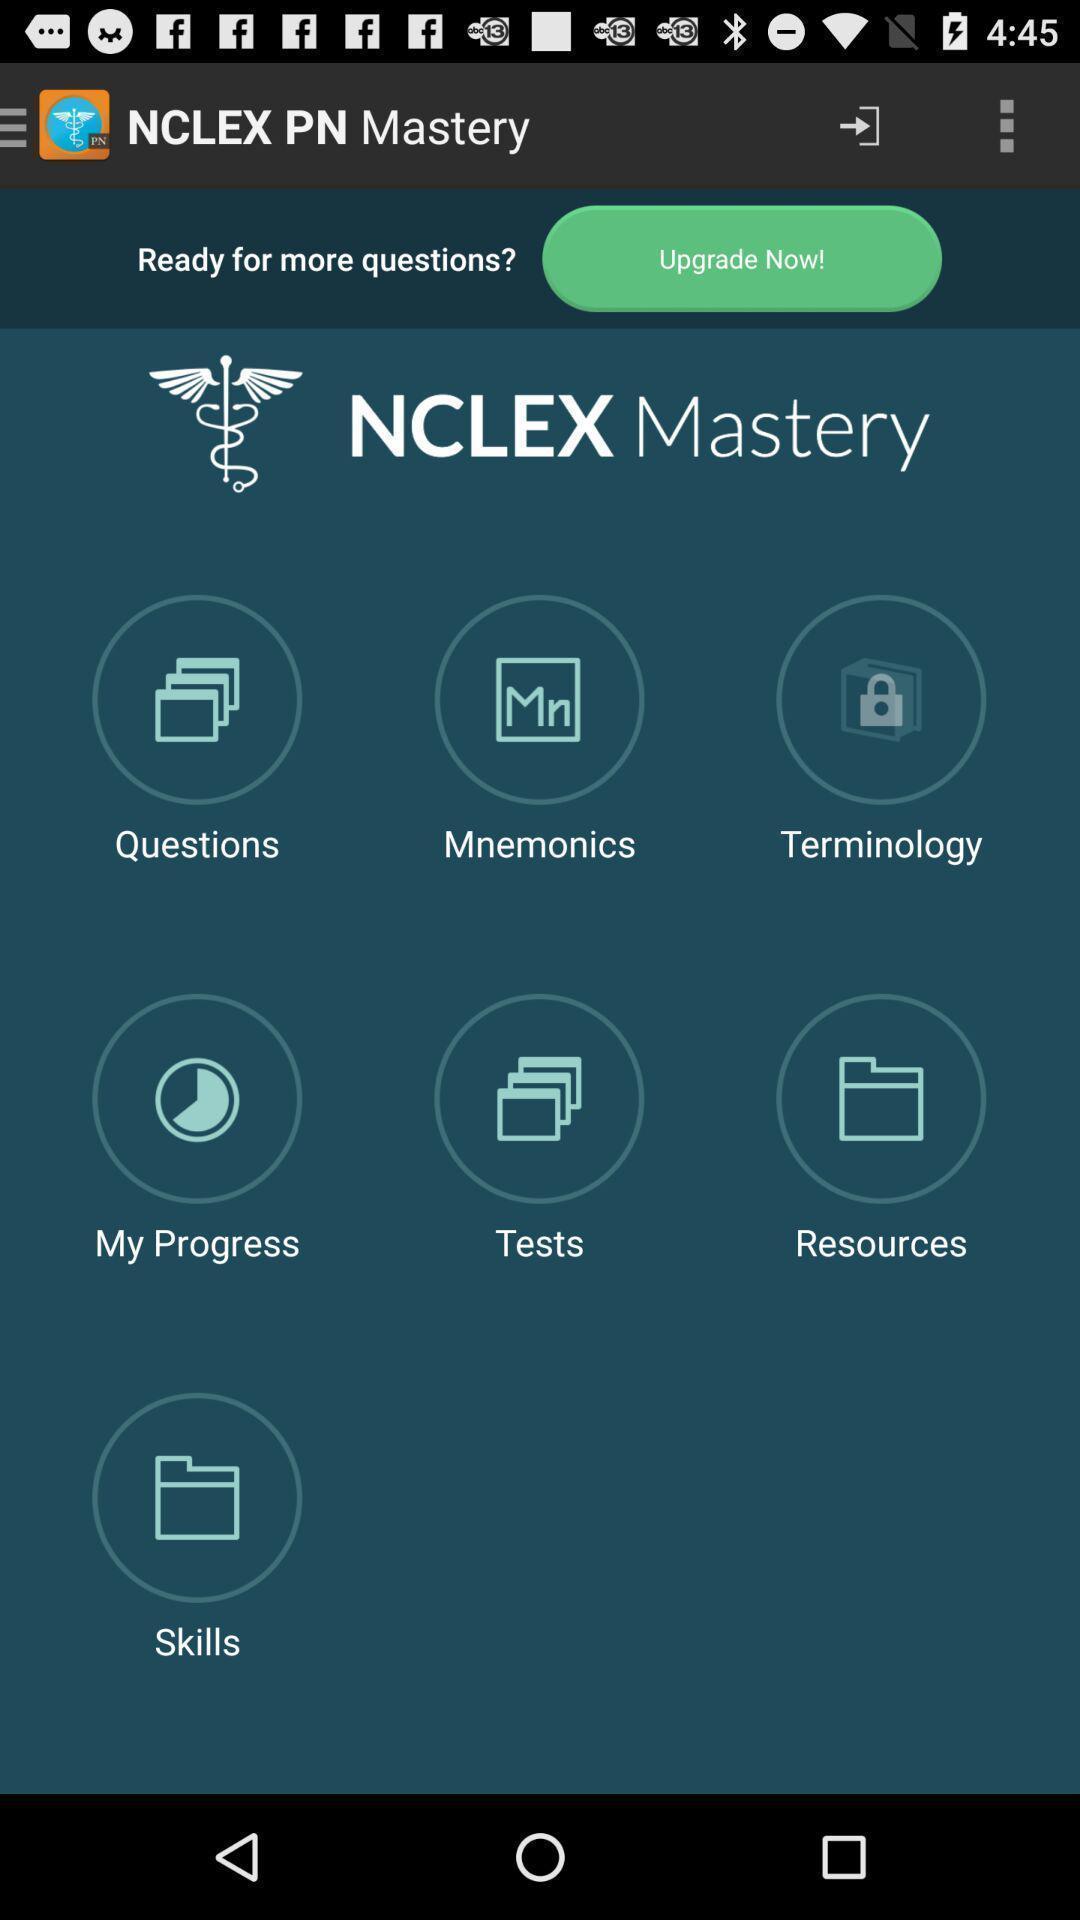Provide a detailed account of this screenshot. Screen display list of various categories in study app. 